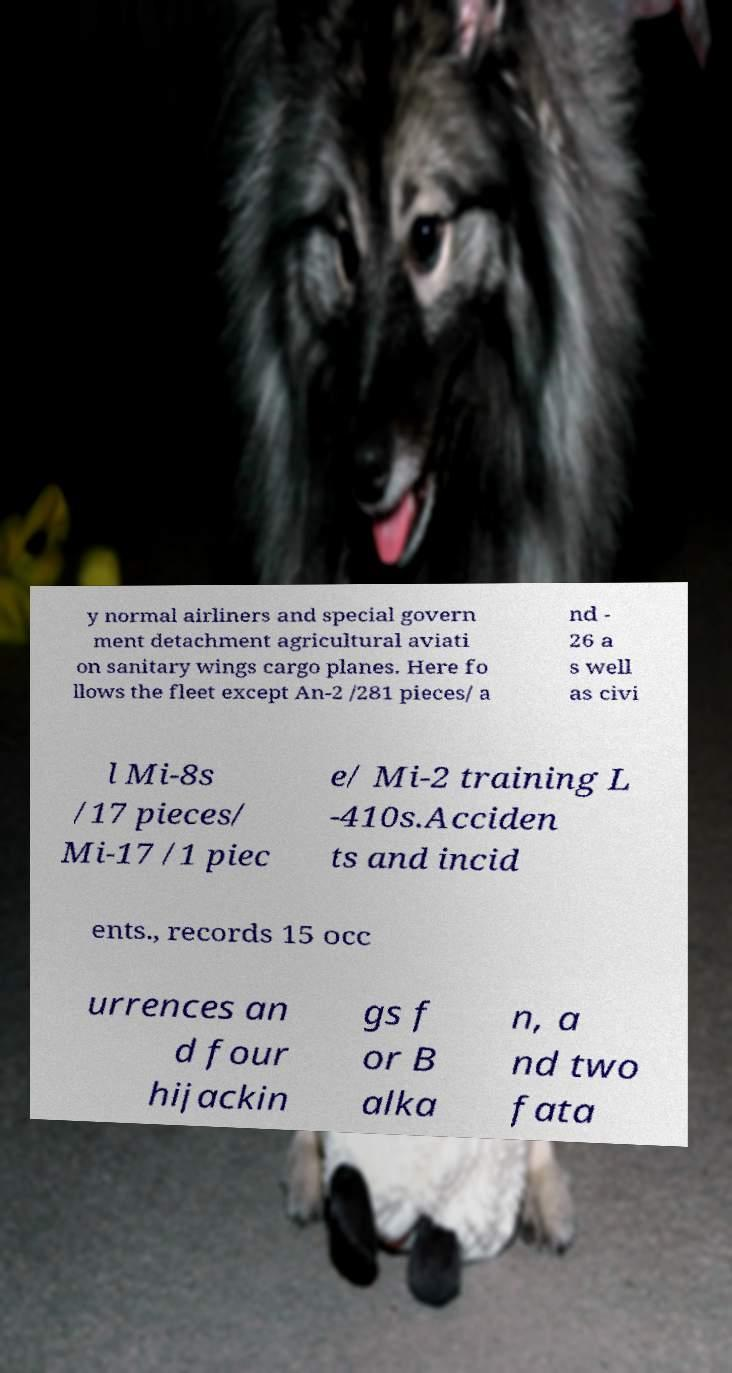Can you read and provide the text displayed in the image?This photo seems to have some interesting text. Can you extract and type it out for me? y normal airliners and special govern ment detachment agricultural aviati on sanitary wings cargo planes. Here fo llows the fleet except An-2 /281 pieces/ a nd - 26 a s well as civi l Mi-8s /17 pieces/ Mi-17 /1 piec e/ Mi-2 training L -410s.Acciden ts and incid ents., records 15 occ urrences an d four hijackin gs f or B alka n, a nd two fata 